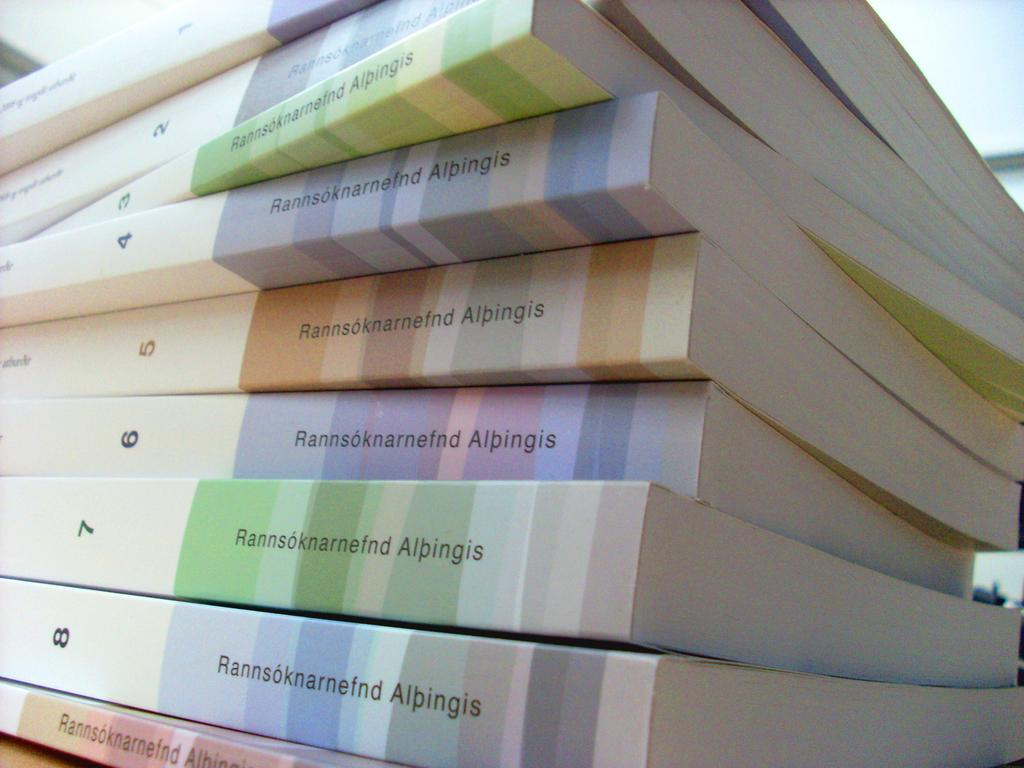<image>
Describe the image concisely. A stack of books numbered from 1 through 8 from Rannsoknarnefnd Albingis 